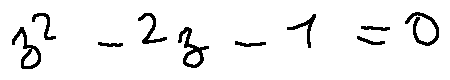<formula> <loc_0><loc_0><loc_500><loc_500>z ^ { 2 } - 2 z - 1 = 0</formula> 